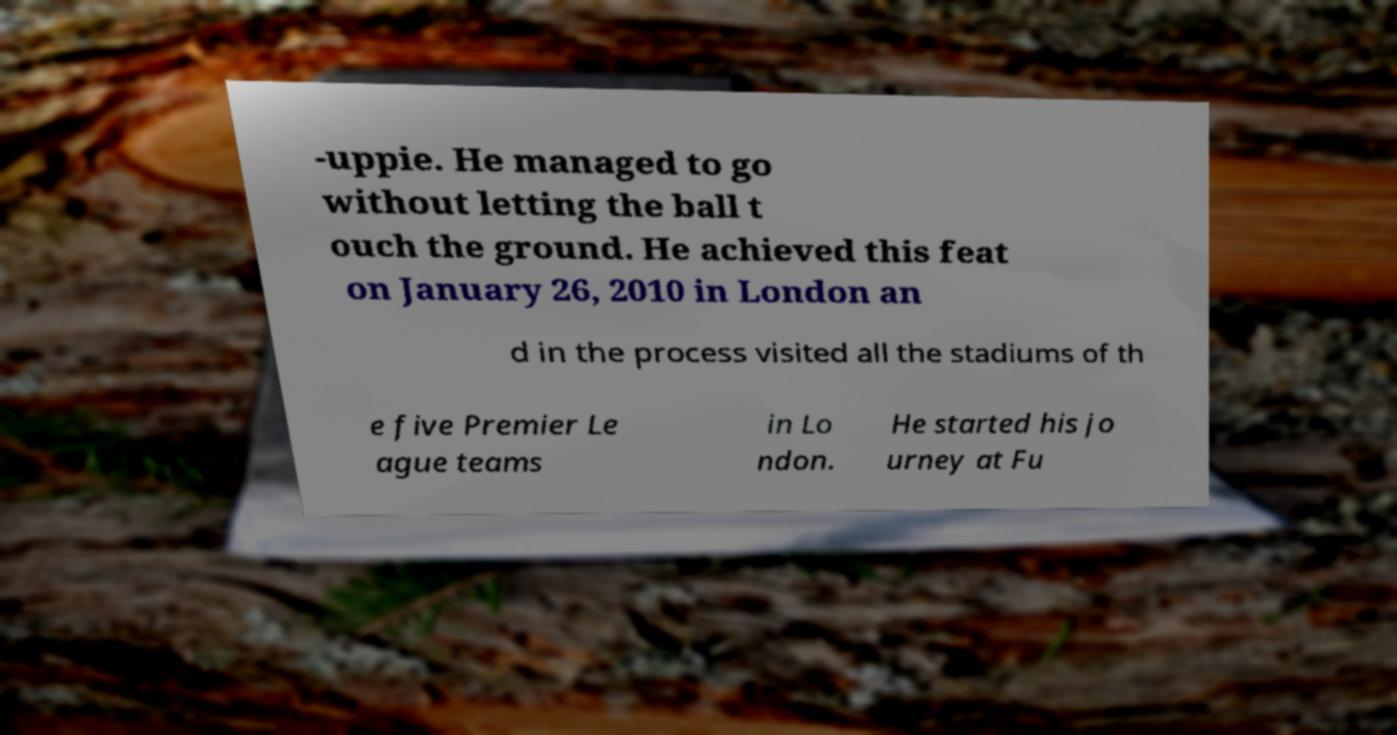For documentation purposes, I need the text within this image transcribed. Could you provide that? -uppie. He managed to go without letting the ball t ouch the ground. He achieved this feat on January 26, 2010 in London an d in the process visited all the stadiums of th e five Premier Le ague teams in Lo ndon. He started his jo urney at Fu 